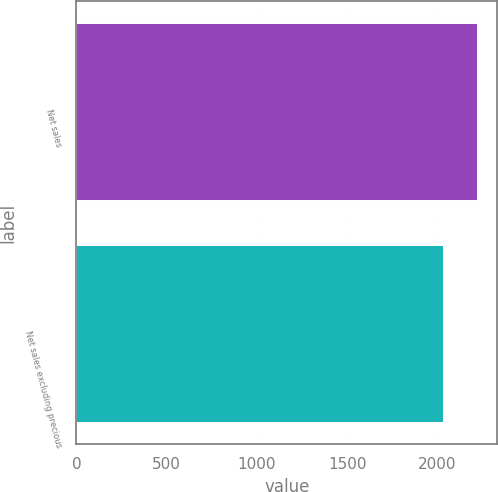Convert chart. <chart><loc_0><loc_0><loc_500><loc_500><bar_chart><fcel>Net sales<fcel>Net sales excluding precious<nl><fcel>2221<fcel>2031.8<nl></chart> 